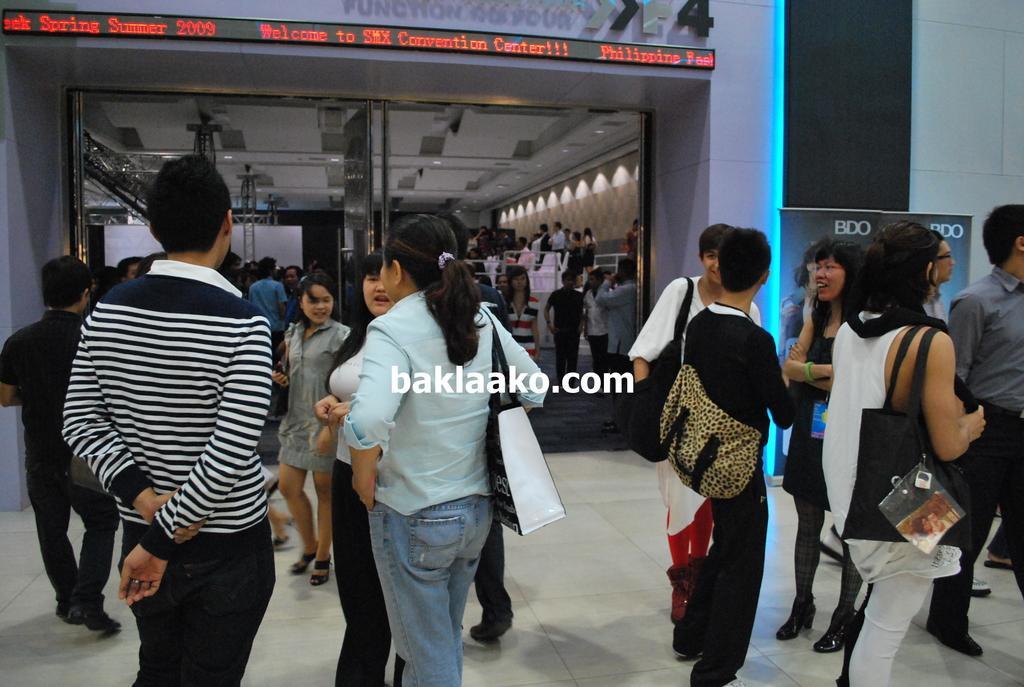How would you summarize this image in a sentence or two? In this image I can see group of people standing on the floor and I can see a glass door , through door I can see crowd of people and lights and the wall. 